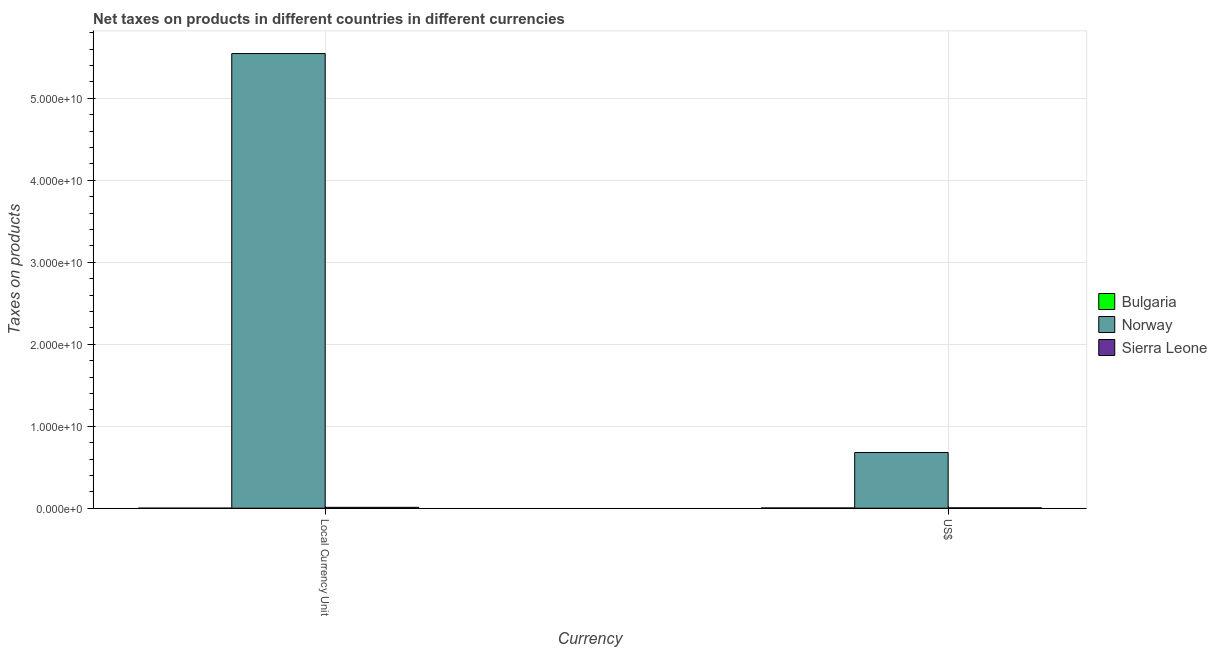How many different coloured bars are there?
Make the answer very short. 3. Are the number of bars on each tick of the X-axis equal?
Offer a very short reply. Yes. How many bars are there on the 2nd tick from the right?
Make the answer very short. 3. What is the label of the 2nd group of bars from the left?
Your answer should be compact. US$. What is the net taxes in us$ in Sierra Leone?
Ensure brevity in your answer.  4.18e+07. Across all countries, what is the maximum net taxes in constant 2005 us$?
Give a very brief answer. 5.55e+1. Across all countries, what is the minimum net taxes in us$?
Provide a succinct answer. 2.78e+07. In which country was the net taxes in constant 2005 us$ maximum?
Your answer should be very brief. Norway. What is the total net taxes in us$ in the graph?
Provide a succinct answer. 6.86e+09. What is the difference between the net taxes in constant 2005 us$ in Bulgaria and that in Sierra Leone?
Your answer should be compact. -1.05e+08. What is the difference between the net taxes in us$ in Norway and the net taxes in constant 2005 us$ in Bulgaria?
Keep it short and to the point. 6.79e+09. What is the average net taxes in us$ per country?
Provide a succinct answer. 2.29e+09. What is the difference between the net taxes in us$ and net taxes in constant 2005 us$ in Norway?
Your answer should be compact. -4.87e+1. What is the ratio of the net taxes in constant 2005 us$ in Norway to that in Bulgaria?
Your answer should be compact. 1.10e+06. Are all the bars in the graph horizontal?
Provide a succinct answer. No. Does the graph contain grids?
Make the answer very short. Yes. Where does the legend appear in the graph?
Offer a very short reply. Center right. How many legend labels are there?
Provide a short and direct response. 3. What is the title of the graph?
Offer a terse response. Net taxes on products in different countries in different currencies. What is the label or title of the X-axis?
Make the answer very short. Currency. What is the label or title of the Y-axis?
Your response must be concise. Taxes on products. What is the Taxes on products of Bulgaria in Local Currency Unit?
Make the answer very short. 5.06e+04. What is the Taxes on products of Norway in Local Currency Unit?
Ensure brevity in your answer.  5.55e+1. What is the Taxes on products of Sierra Leone in Local Currency Unit?
Ensure brevity in your answer.  1.05e+08. What is the Taxes on products in Bulgaria in US$?
Offer a very short reply. 2.78e+07. What is the Taxes on products of Norway in US$?
Your answer should be very brief. 6.79e+09. What is the Taxes on products in Sierra Leone in US$?
Ensure brevity in your answer.  4.18e+07. Across all Currency, what is the maximum Taxes on products of Bulgaria?
Provide a short and direct response. 2.78e+07. Across all Currency, what is the maximum Taxes on products in Norway?
Your answer should be very brief. 5.55e+1. Across all Currency, what is the maximum Taxes on products of Sierra Leone?
Make the answer very short. 1.05e+08. Across all Currency, what is the minimum Taxes on products of Bulgaria?
Offer a very short reply. 5.06e+04. Across all Currency, what is the minimum Taxes on products in Norway?
Your response must be concise. 6.79e+09. Across all Currency, what is the minimum Taxes on products in Sierra Leone?
Your answer should be very brief. 4.18e+07. What is the total Taxes on products of Bulgaria in the graph?
Provide a succinct answer. 2.79e+07. What is the total Taxes on products in Norway in the graph?
Provide a succinct answer. 6.22e+1. What is the total Taxes on products in Sierra Leone in the graph?
Provide a succinct answer. 1.47e+08. What is the difference between the Taxes on products in Bulgaria in Local Currency Unit and that in US$?
Offer a very short reply. -2.78e+07. What is the difference between the Taxes on products of Norway in Local Currency Unit and that in US$?
Offer a terse response. 4.87e+1. What is the difference between the Taxes on products of Sierra Leone in Local Currency Unit and that in US$?
Your response must be concise. 6.32e+07. What is the difference between the Taxes on products of Bulgaria in Local Currency Unit and the Taxes on products of Norway in US$?
Your answer should be very brief. -6.79e+09. What is the difference between the Taxes on products in Bulgaria in Local Currency Unit and the Taxes on products in Sierra Leone in US$?
Offer a very short reply. -4.18e+07. What is the difference between the Taxes on products of Norway in Local Currency Unit and the Taxes on products of Sierra Leone in US$?
Your answer should be very brief. 5.54e+1. What is the average Taxes on products in Bulgaria per Currency?
Keep it short and to the point. 1.39e+07. What is the average Taxes on products of Norway per Currency?
Offer a terse response. 3.11e+1. What is the average Taxes on products in Sierra Leone per Currency?
Your answer should be compact. 7.34e+07. What is the difference between the Taxes on products in Bulgaria and Taxes on products in Norway in Local Currency Unit?
Provide a succinct answer. -5.55e+1. What is the difference between the Taxes on products of Bulgaria and Taxes on products of Sierra Leone in Local Currency Unit?
Your answer should be compact. -1.05e+08. What is the difference between the Taxes on products in Norway and Taxes on products in Sierra Leone in Local Currency Unit?
Your response must be concise. 5.53e+1. What is the difference between the Taxes on products in Bulgaria and Taxes on products in Norway in US$?
Your response must be concise. -6.77e+09. What is the difference between the Taxes on products of Bulgaria and Taxes on products of Sierra Leone in US$?
Offer a very short reply. -1.40e+07. What is the difference between the Taxes on products of Norway and Taxes on products of Sierra Leone in US$?
Offer a very short reply. 6.75e+09. What is the ratio of the Taxes on products in Bulgaria in Local Currency Unit to that in US$?
Your response must be concise. 0. What is the ratio of the Taxes on products in Norway in Local Currency Unit to that in US$?
Offer a very short reply. 8.16. What is the ratio of the Taxes on products in Sierra Leone in Local Currency Unit to that in US$?
Provide a succinct answer. 2.51. What is the difference between the highest and the second highest Taxes on products in Bulgaria?
Your answer should be compact. 2.78e+07. What is the difference between the highest and the second highest Taxes on products of Norway?
Your answer should be compact. 4.87e+1. What is the difference between the highest and the second highest Taxes on products in Sierra Leone?
Offer a terse response. 6.32e+07. What is the difference between the highest and the lowest Taxes on products of Bulgaria?
Your answer should be very brief. 2.78e+07. What is the difference between the highest and the lowest Taxes on products of Norway?
Make the answer very short. 4.87e+1. What is the difference between the highest and the lowest Taxes on products in Sierra Leone?
Offer a terse response. 6.32e+07. 